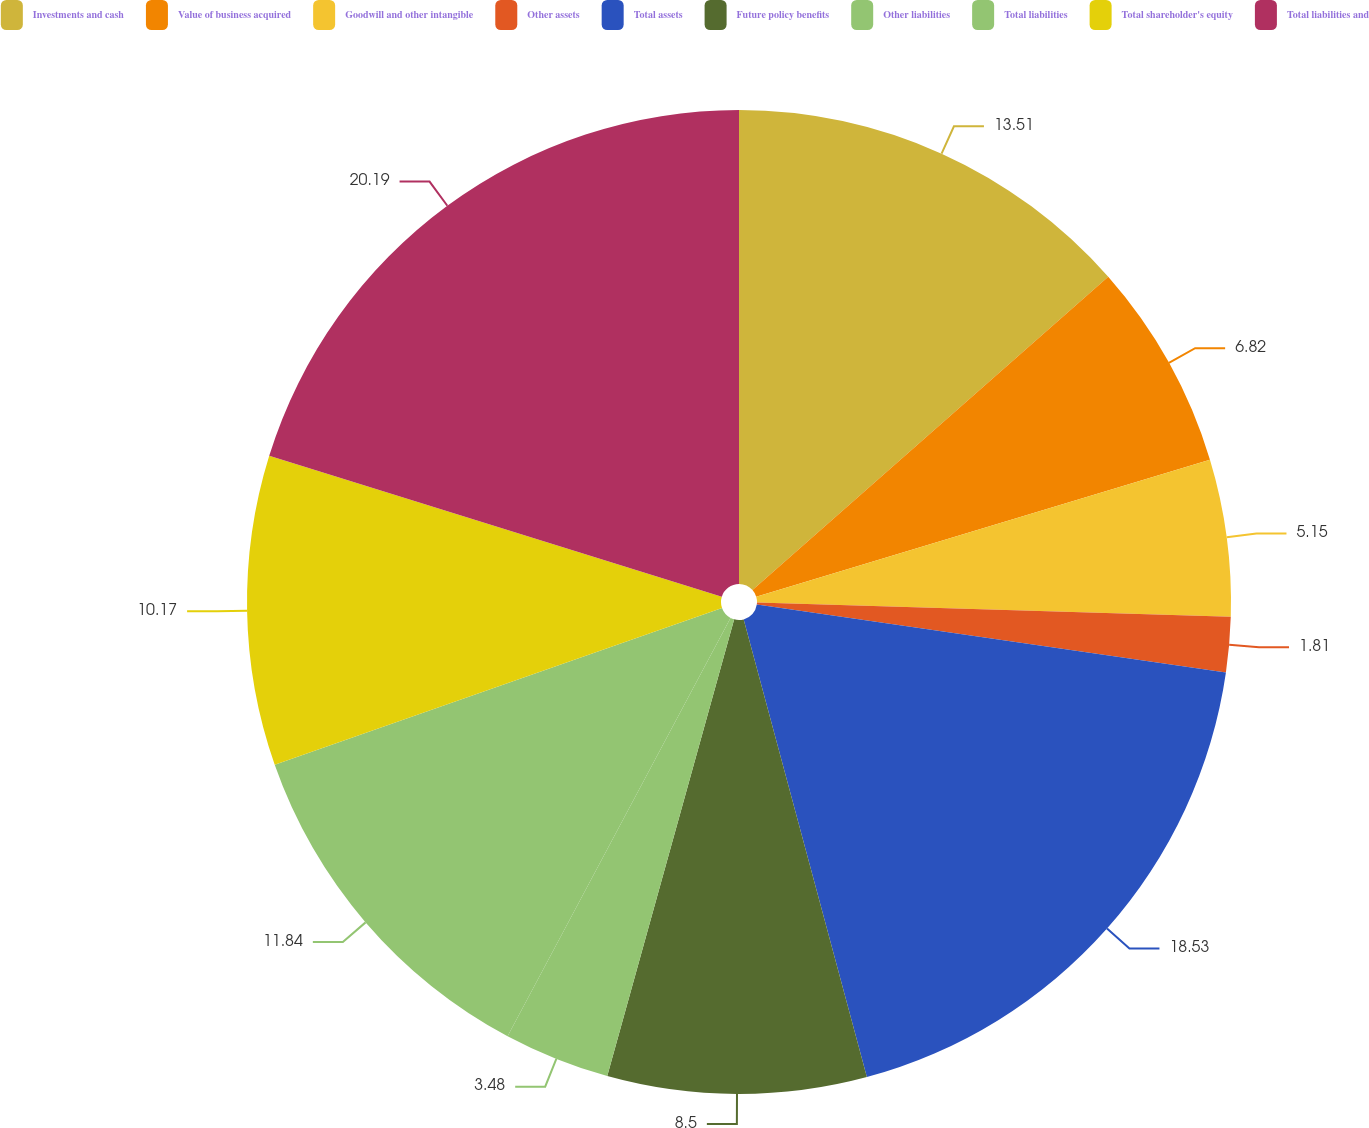Convert chart. <chart><loc_0><loc_0><loc_500><loc_500><pie_chart><fcel>Investments and cash<fcel>Value of business acquired<fcel>Goodwill and other intangible<fcel>Other assets<fcel>Total assets<fcel>Future policy benefits<fcel>Other liabilities<fcel>Total liabilities<fcel>Total shareholder's equity<fcel>Total liabilities and<nl><fcel>13.51%<fcel>6.82%<fcel>5.15%<fcel>1.81%<fcel>18.53%<fcel>8.5%<fcel>3.48%<fcel>11.84%<fcel>10.17%<fcel>20.2%<nl></chart> 